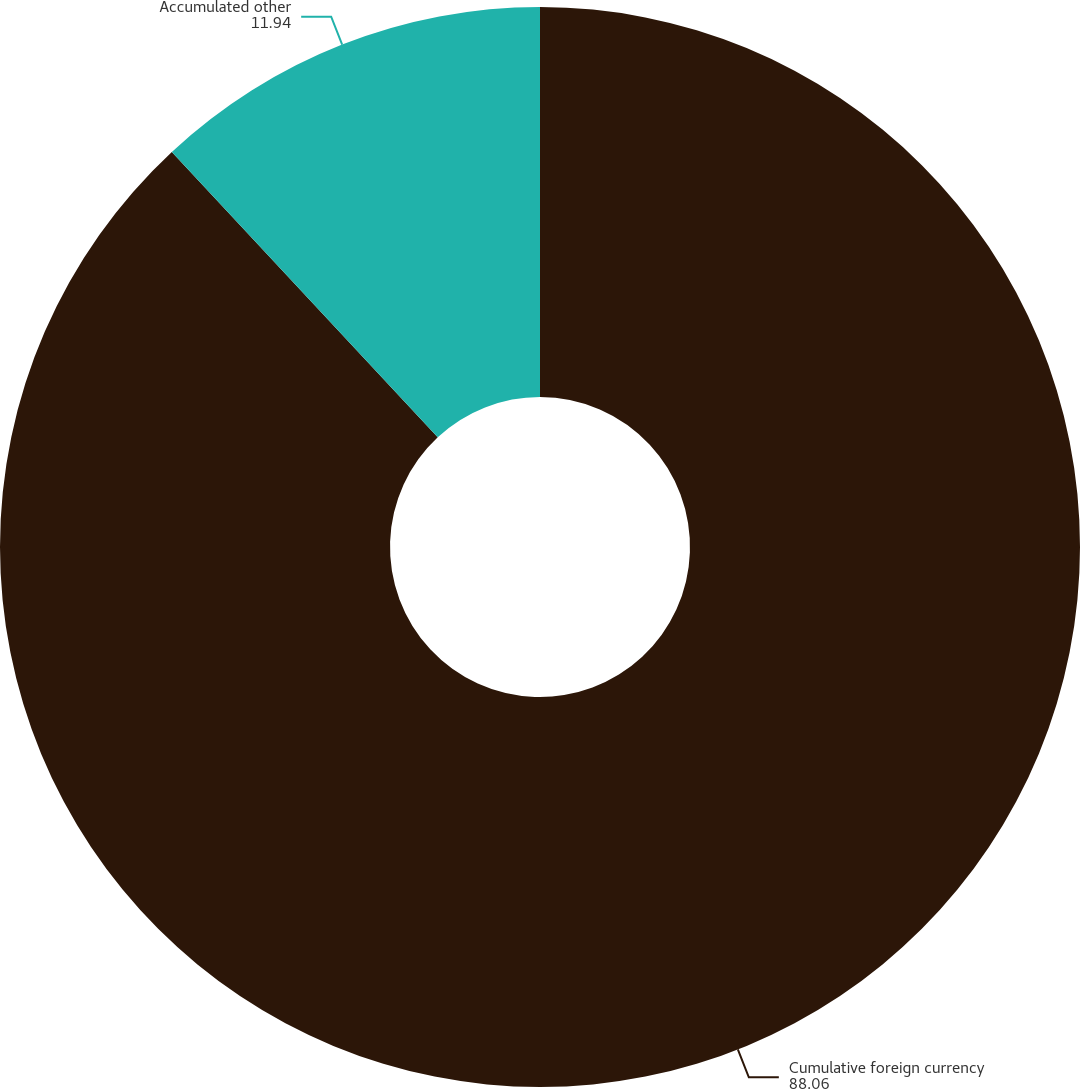Convert chart. <chart><loc_0><loc_0><loc_500><loc_500><pie_chart><fcel>Cumulative foreign currency<fcel>Accumulated other<nl><fcel>88.06%<fcel>11.94%<nl></chart> 